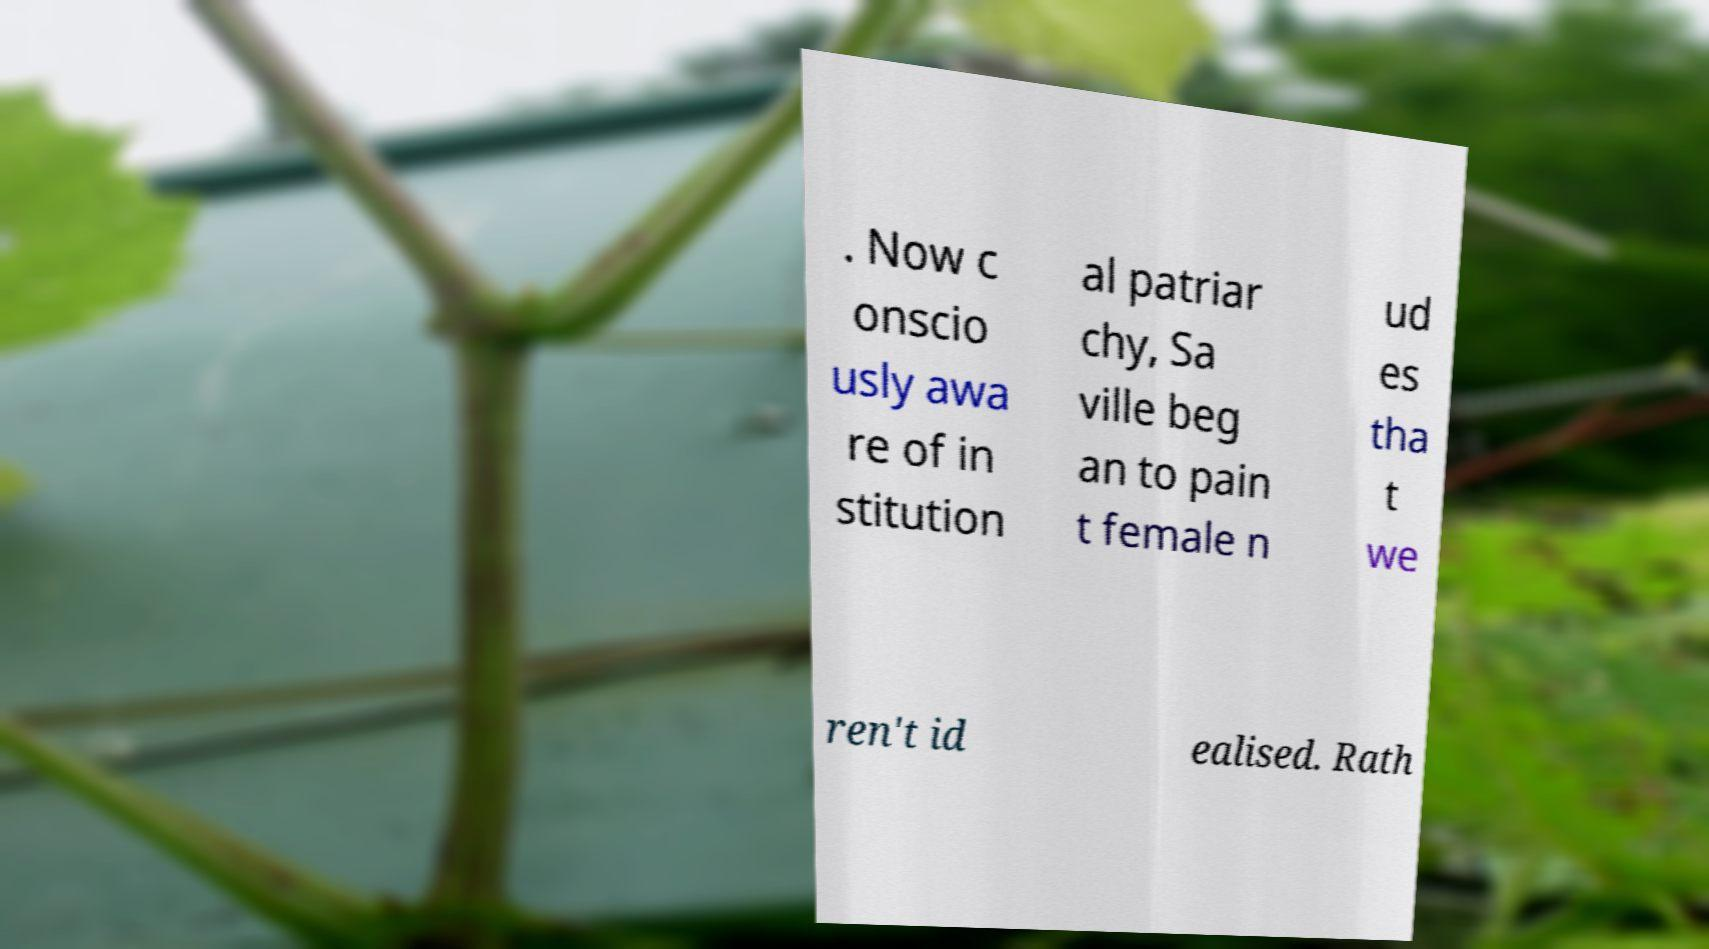Could you assist in decoding the text presented in this image and type it out clearly? . Now c onscio usly awa re of in stitution al patriar chy, Sa ville beg an to pain t female n ud es tha t we ren't id ealised. Rath 